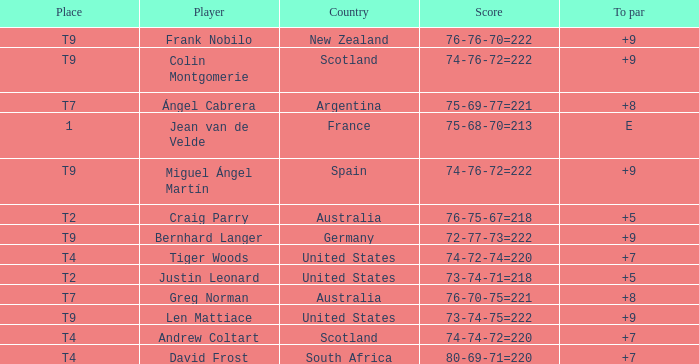Which player from the United States is in a place of T2? Justin Leonard. 